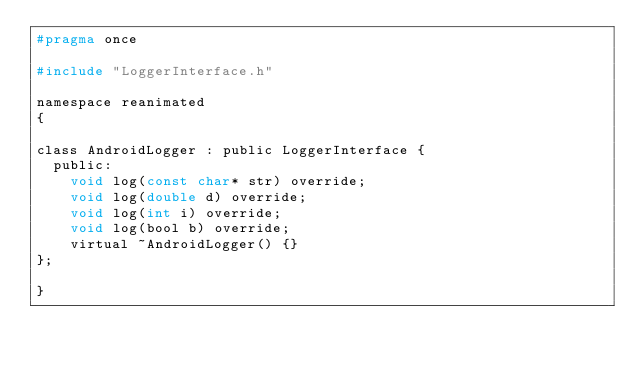Convert code to text. <code><loc_0><loc_0><loc_500><loc_500><_C_>#pragma once

#include "LoggerInterface.h"

namespace reanimated
{

class AndroidLogger : public LoggerInterface {
  public:
    void log(const char* str) override;
    void log(double d) override;
    void log(int i) override;
    void log(bool b) override;
    virtual ~AndroidLogger() {}
};

}
</code> 